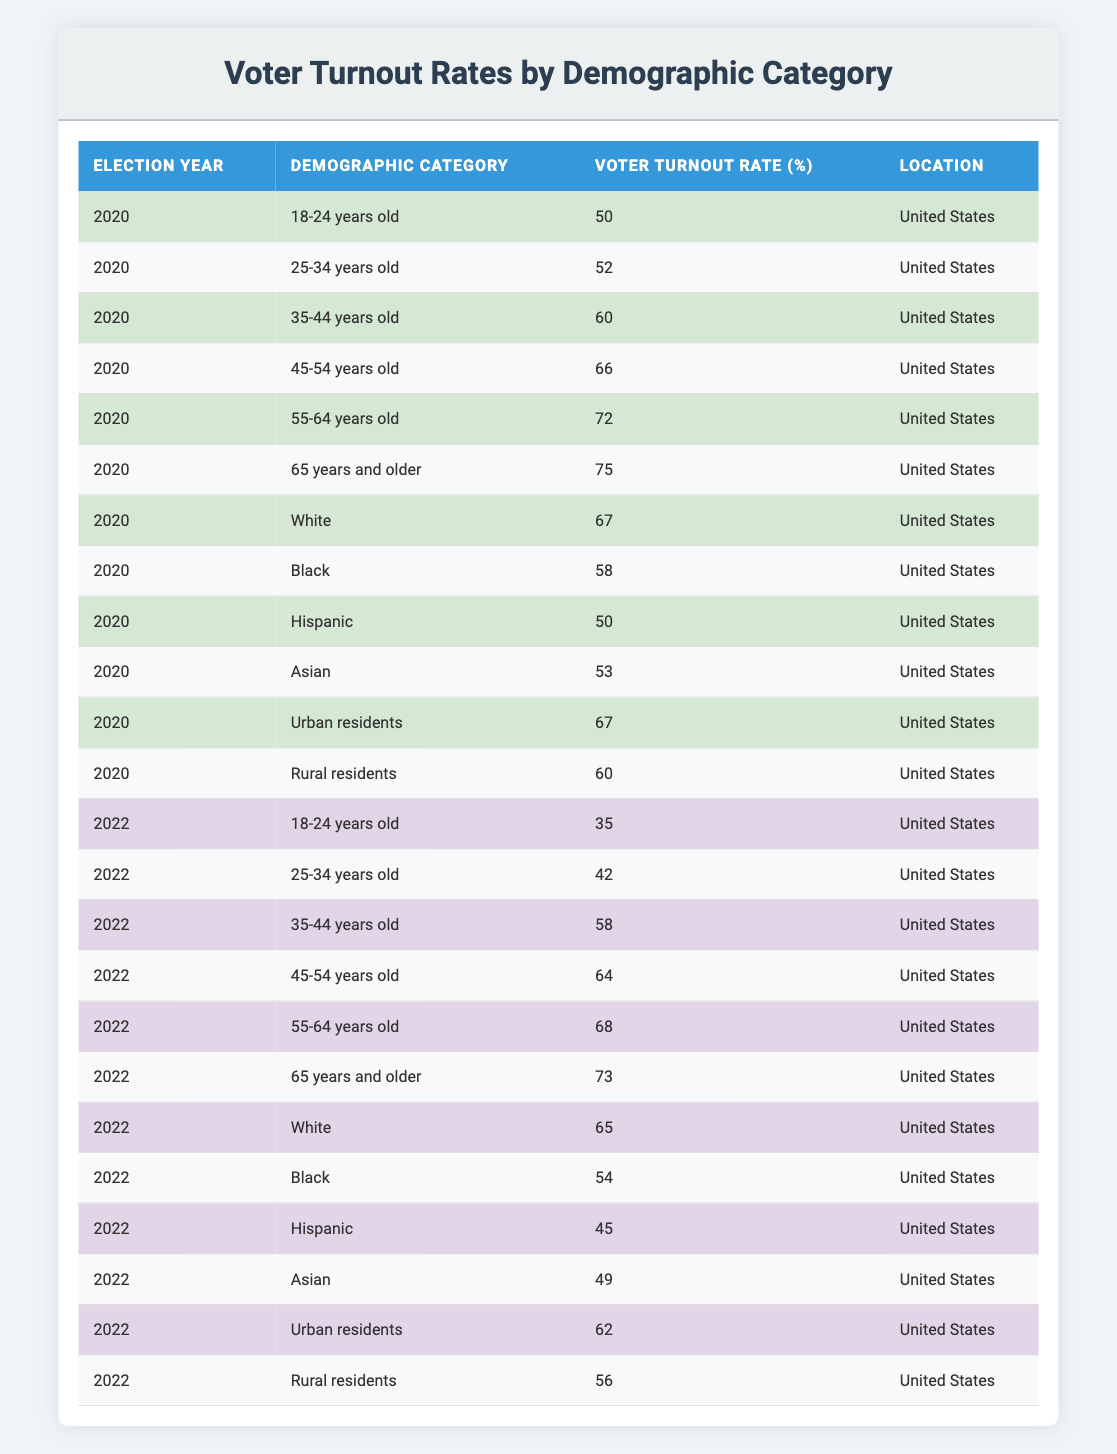What was the voter turnout rate for 18-24 year olds in the 2020 election? The table shows that the voter turnout rate for 18-24 year olds in the 2020 election is 50%.
Answer: 50% What demographic category had the highest voter turnout rate in 2022? By examining the table for 2022, the demographic category with the highest voter turnout rate is "65 years and older" with a rate of 73%.
Answer: 73% What is the difference in voter turnout rates for Hispanic voters between the 2020 and 2022 elections? For Hispanic voters, the turnout rate in 2020 is 50%, while in 2022 it is 45%. The difference is calculated by subtracting 45 from 50, which equals 5%.
Answer: 5% Is the voter turnout rate higher for urban residents than for rural residents in the 2020 election? The voter turnout rate for urban residents in 2020 is 67%, while for rural residents, it is 60%. Thus, yes, urban residents had a higher turnout rate.
Answer: Yes What was the average voter turnout rate for those aged 25-44 in the 2020 election? The rates for the age groups 25-34 (52%), 35-44 (60%) can be added together, which totals 112%. Dividing by 2 gives the average turnout rate: 112% / 2 = 56%.
Answer: 56% How many demographic categories had a voter turnout rate of 60% or higher in 2022? In 2022, the demographic categories with a turnout rate of 60% or higher are: "65 years and older" (73%), "55-64 years old" (68%), and "Urban residents" (62%). This totals 3 categories.
Answer: 3 Did the voter turnout rate for Black voters increase or decrease from 2020 to 2022? The rate for Black voters in 2020 is 58%, and in 2022 it is 54%. This indicates a decrease.
Answer: Decrease Which age group saw the largest decline in voter turnout from 2020 to 2022? Comparing the rates for age groups, 18-24 years (50% to 35%, a decline of 15%) and 25-34 years (52% to 42%, a decline of 10%), the largest decline is among the 18-24 year olds with a decrease of 15%.
Answer: 15% 